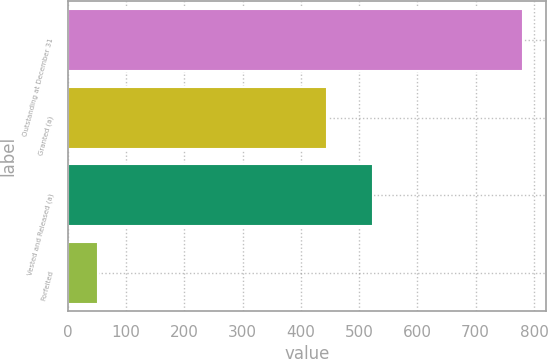Convert chart. <chart><loc_0><loc_0><loc_500><loc_500><bar_chart><fcel>Outstanding at December 31<fcel>Granted (a)<fcel>Vested and Released (a)<fcel>Forfeited<nl><fcel>781<fcel>445<fcel>523.4<fcel>51<nl></chart> 